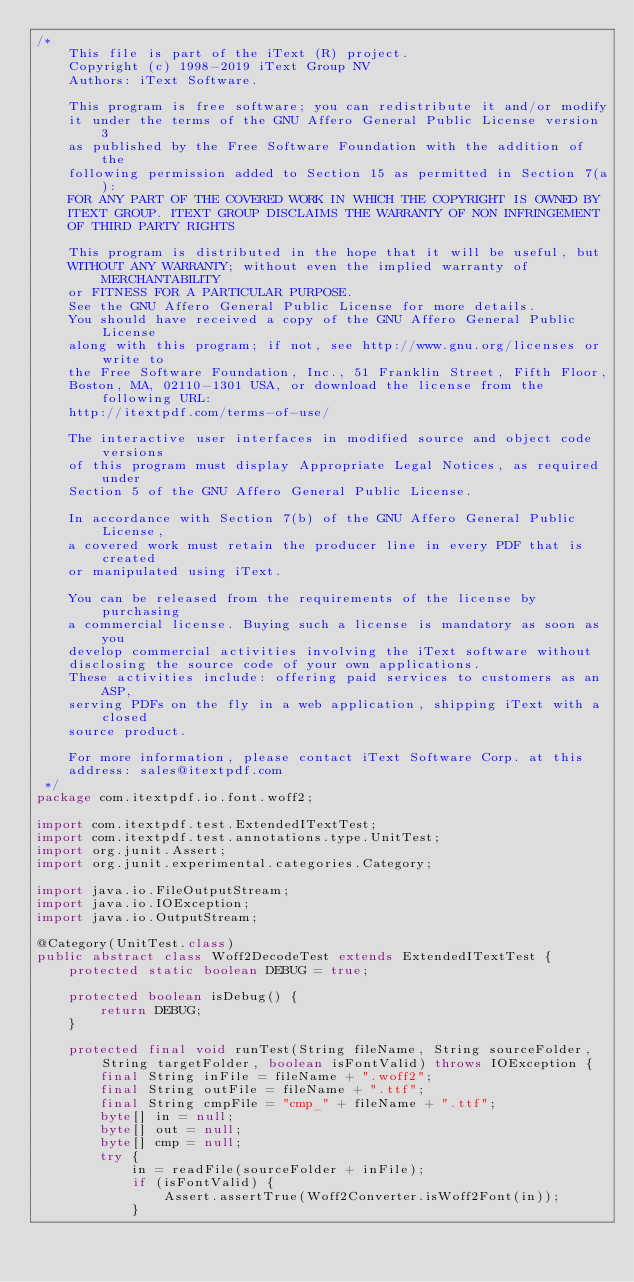<code> <loc_0><loc_0><loc_500><loc_500><_Java_>/*
    This file is part of the iText (R) project.
    Copyright (c) 1998-2019 iText Group NV
    Authors: iText Software.

    This program is free software; you can redistribute it and/or modify
    it under the terms of the GNU Affero General Public License version 3
    as published by the Free Software Foundation with the addition of the
    following permission added to Section 15 as permitted in Section 7(a):
    FOR ANY PART OF THE COVERED WORK IN WHICH THE COPYRIGHT IS OWNED BY
    ITEXT GROUP. ITEXT GROUP DISCLAIMS THE WARRANTY OF NON INFRINGEMENT
    OF THIRD PARTY RIGHTS

    This program is distributed in the hope that it will be useful, but
    WITHOUT ANY WARRANTY; without even the implied warranty of MERCHANTABILITY
    or FITNESS FOR A PARTICULAR PURPOSE.
    See the GNU Affero General Public License for more details.
    You should have received a copy of the GNU Affero General Public License
    along with this program; if not, see http://www.gnu.org/licenses or write to
    the Free Software Foundation, Inc., 51 Franklin Street, Fifth Floor,
    Boston, MA, 02110-1301 USA, or download the license from the following URL:
    http://itextpdf.com/terms-of-use/

    The interactive user interfaces in modified source and object code versions
    of this program must display Appropriate Legal Notices, as required under
    Section 5 of the GNU Affero General Public License.

    In accordance with Section 7(b) of the GNU Affero General Public License,
    a covered work must retain the producer line in every PDF that is created
    or manipulated using iText.

    You can be released from the requirements of the license by purchasing
    a commercial license. Buying such a license is mandatory as soon as you
    develop commercial activities involving the iText software without
    disclosing the source code of your own applications.
    These activities include: offering paid services to customers as an ASP,
    serving PDFs on the fly in a web application, shipping iText with a closed
    source product.

    For more information, please contact iText Software Corp. at this
    address: sales@itextpdf.com
 */
package com.itextpdf.io.font.woff2;

import com.itextpdf.test.ExtendedITextTest;
import com.itextpdf.test.annotations.type.UnitTest;
import org.junit.Assert;
import org.junit.experimental.categories.Category;

import java.io.FileOutputStream;
import java.io.IOException;
import java.io.OutputStream;

@Category(UnitTest.class)
public abstract class Woff2DecodeTest extends ExtendedITextTest {
    protected static boolean DEBUG = true;

    protected boolean isDebug() {
        return DEBUG;
    }

    protected final void runTest(String fileName, String sourceFolder, String targetFolder, boolean isFontValid) throws IOException {
        final String inFile = fileName + ".woff2";
        final String outFile = fileName + ".ttf";
        final String cmpFile = "cmp_" + fileName + ".ttf";
        byte[] in = null;
        byte[] out = null;
        byte[] cmp = null;
        try {
            in = readFile(sourceFolder + inFile);
            if (isFontValid) {
                Assert.assertTrue(Woff2Converter.isWoff2Font(in));
            }</code> 